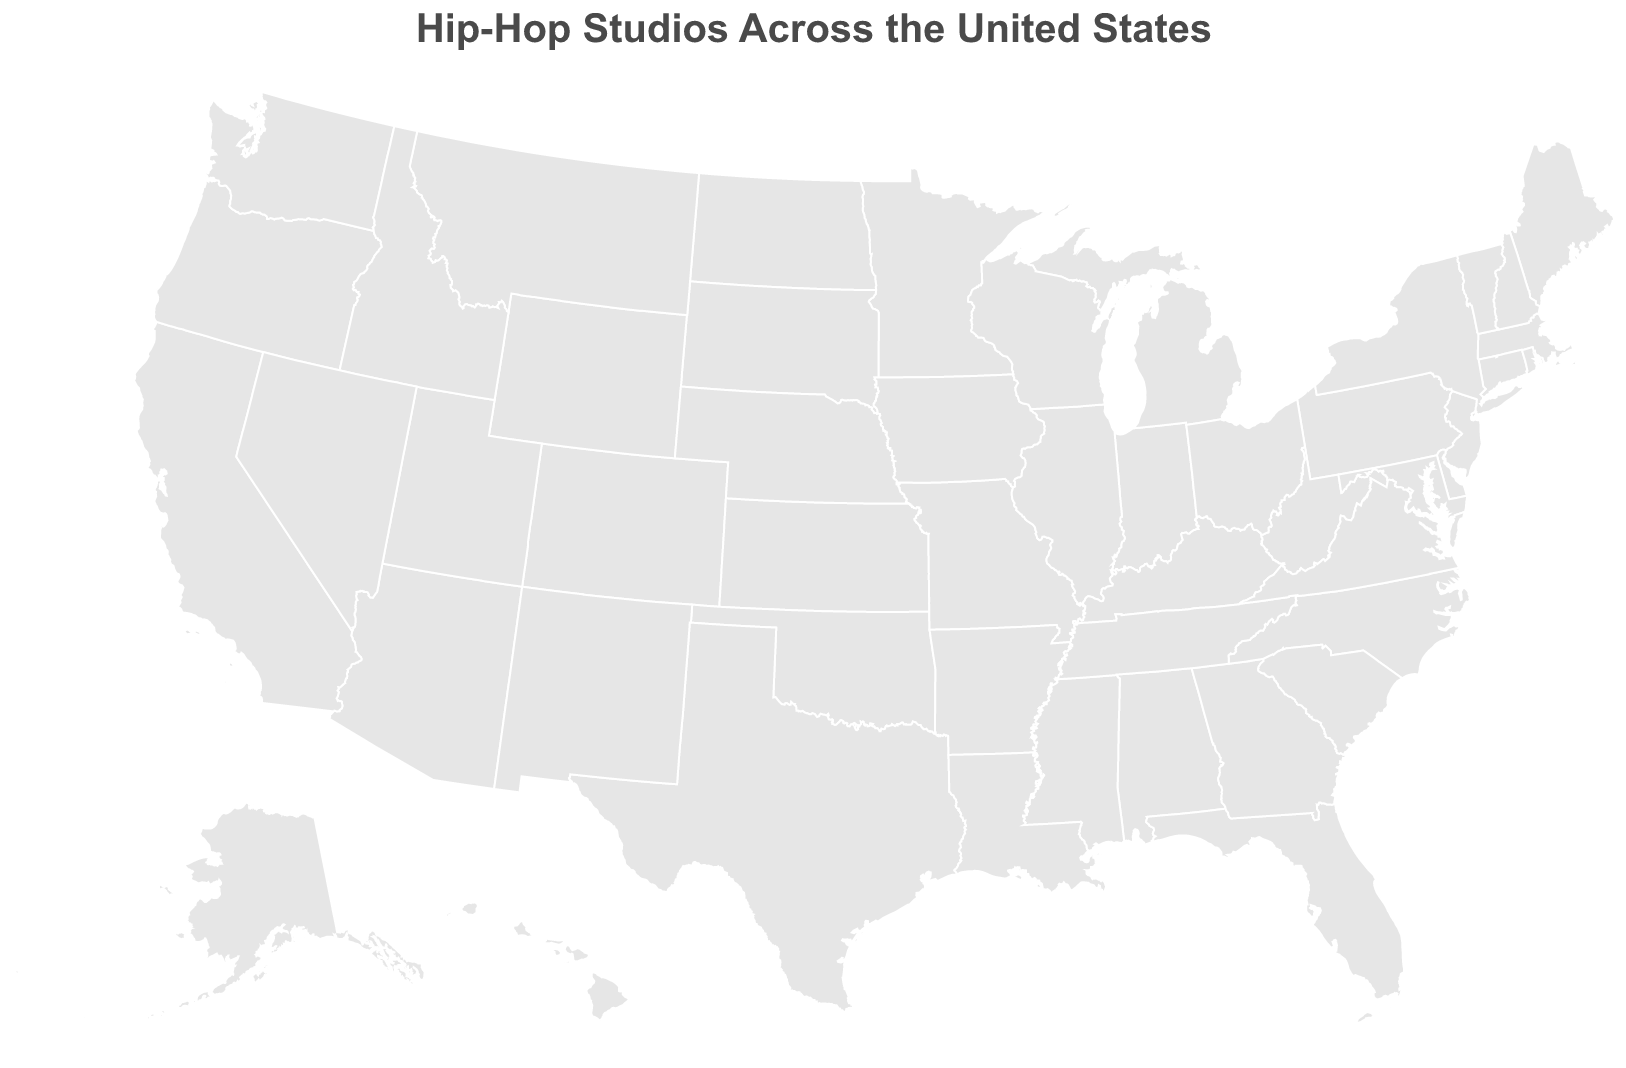What is the title of the figure? The title of a figure usually appears at the top, prominently displayed. In this case, the title is "Hip-Hop Studios Across the United States."
Answer: Hip-Hop Studios Across the United States How many recording studios are shown on the map? By visually counting the number of circles, which represent the recording studios, we can determine the total number.
Answer: 10 Which city hosts the studio with the highest Hip-Hop Focus Score? Look for the city whose circle (representing a studio) is the largest and has the most intense color, indicating the highest score. Based on the data, it's clear that "New York City" hosts Def Jam Studios with a score of 95.
Answer: New York City What's the location (latitude and longitude) of the studio in Houston? Find the circle that corresponds to Houston and check the tooltip or legend for its coordinates. According to the data, Houston is represented with coordinates (29.7604, -95.3698).
Answer: 29.7604, -95.3698 Compare the Hip-Hop Focus Scores between Def Jam Studios in New York City and Death Row Records Studio in Los Angeles. Check the scores for both studios. Def Jam Studios has a score of 95, while Death Row Records Studio has a score of 90. So, Def Jam Studios has a higher score compared to Death Row Records Studio.
Answer: Def Jam Studios has a higher score (95 vs 90) Which studio has the smallest Hip-Hop Focus Score, and what is that score? Identify the studio with the smallest circle and color intensity on the map or check the data directly. The studio with the smallest score is Hypnotize Minds Studio in Memphis, with a score of 77.
Answer: Hypnotize Minds Studio, 77 Which regions (East Coast vs. West Coast) have more studios based on the figure? Count the number of studios on the East Coast and West Coast by looking at the distribution of circles. East Coast has studios in New York City, Philadelphia, and Miami. West Coast has studios in Los Angeles.
Answer: East Coast has more studios What's the average Hip-Hop Focus Score for studios in the Southern United States (Atlanta, Miami, New Orleans, Memphis)? Add up the scores for the studios in these cities and divide by the number of studios: Atlanta (88), Miami (86), New Orleans (79), Memphis (77). The total is 330 derived by summation (88 + 86 + 79 + 77); then divide by 4 to get the average: 330 / 4 = 82.5.
Answer: 82.5 Which studio appears in Philadelphia according to the map? Check the coordinates for the Philadelphia city location and its corresponding circle to find the studio name, which is The Roots' Studio.
Answer: The Roots' Studio Is there any studio with a score greater than 90? If so, name it. Look for circles with the size and color representing scores higher than 90. According to the data, Def Jam Studios in New York City is the only one with a score of 95, which is greater than 90.
Answer: Def Jam Studios 